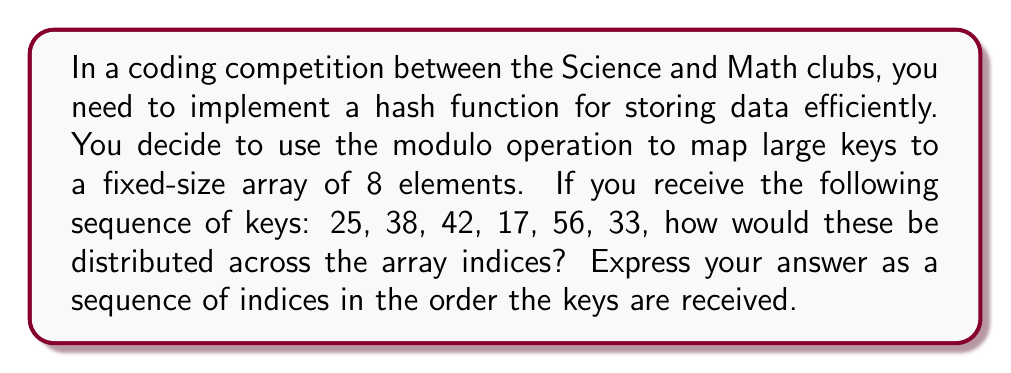Teach me how to tackle this problem. To solve this problem, we need to apply modular arithmetic. The hash function will map each key to an index in the array by taking the remainder when the key is divided by the array size.

Given:
- Array size = 8
- Keys = 25, 38, 42, 17, 56, 33

Let's calculate the index for each key:

1. For 25: 
   $25 \bmod 8 = 1$ (because $25 = 3 \times 8 + 1$)

2. For 38:
   $38 \bmod 8 = 6$ (because $38 = 4 \times 8 + 6$)

3. For 42:
   $42 \bmod 8 = 2$ (because $42 = 5 \times 8 + 2$)

4. For 17:
   $17 \bmod 8 = 1$ (because $17 = 2 \times 8 + 1$)

5. For 56:
   $56 \bmod 8 = 0$ (because $56 = 7 \times 8 + 0$)

6. For 33:
   $33 \bmod 8 = 1$ (because $33 = 4 \times 8 + 1$)

The resulting sequence of indices is therefore 1, 6, 2, 1, 0, 1.

Note that there are collisions at index 1, which would require additional handling in a real hash table implementation.
Answer: 1, 6, 2, 1, 0, 1 